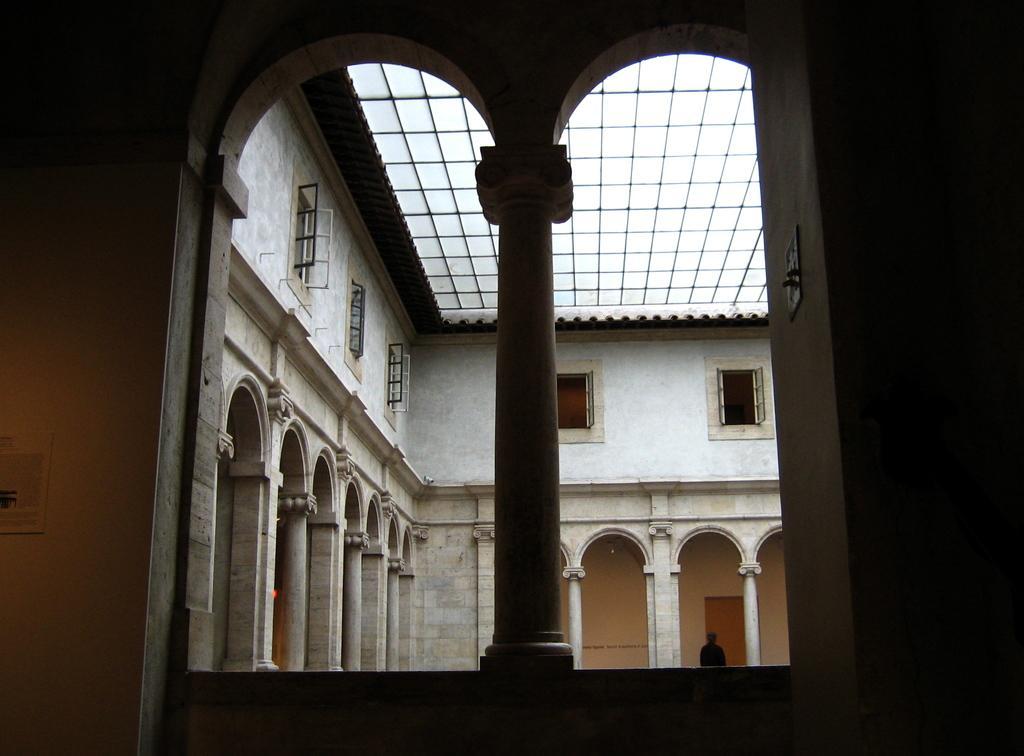How would you summarize this image in a sentence or two? This is the inside picture of the building. In this image there are pillars. There are windows. There is a wall. In the background of the image there is a person standing in front of the door. On the left side of the image there is a poster attached to the wall. 